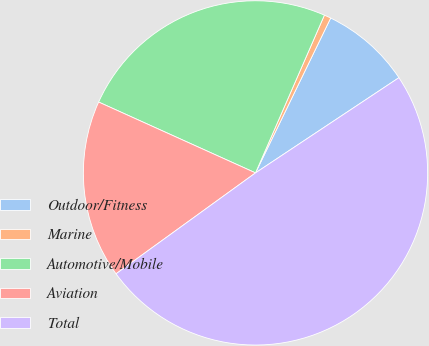<chart> <loc_0><loc_0><loc_500><loc_500><pie_chart><fcel>Outdoor/Fitness<fcel>Marine<fcel>Automotive/Mobile<fcel>Aviation<fcel>Total<nl><fcel>8.48%<fcel>0.64%<fcel>24.8%<fcel>16.72%<fcel>49.36%<nl></chart> 